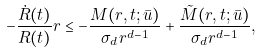Convert formula to latex. <formula><loc_0><loc_0><loc_500><loc_500>- \frac { \dot { R } ( t ) } { R ( t ) } r \leq - \frac { M ( r , t ; \bar { u } ) } { \sigma _ { d } r ^ { d - 1 } } + \frac { \tilde { M } ( r , t ; \bar { u } ) } { \sigma _ { d } r ^ { d - 1 } } ,</formula> 